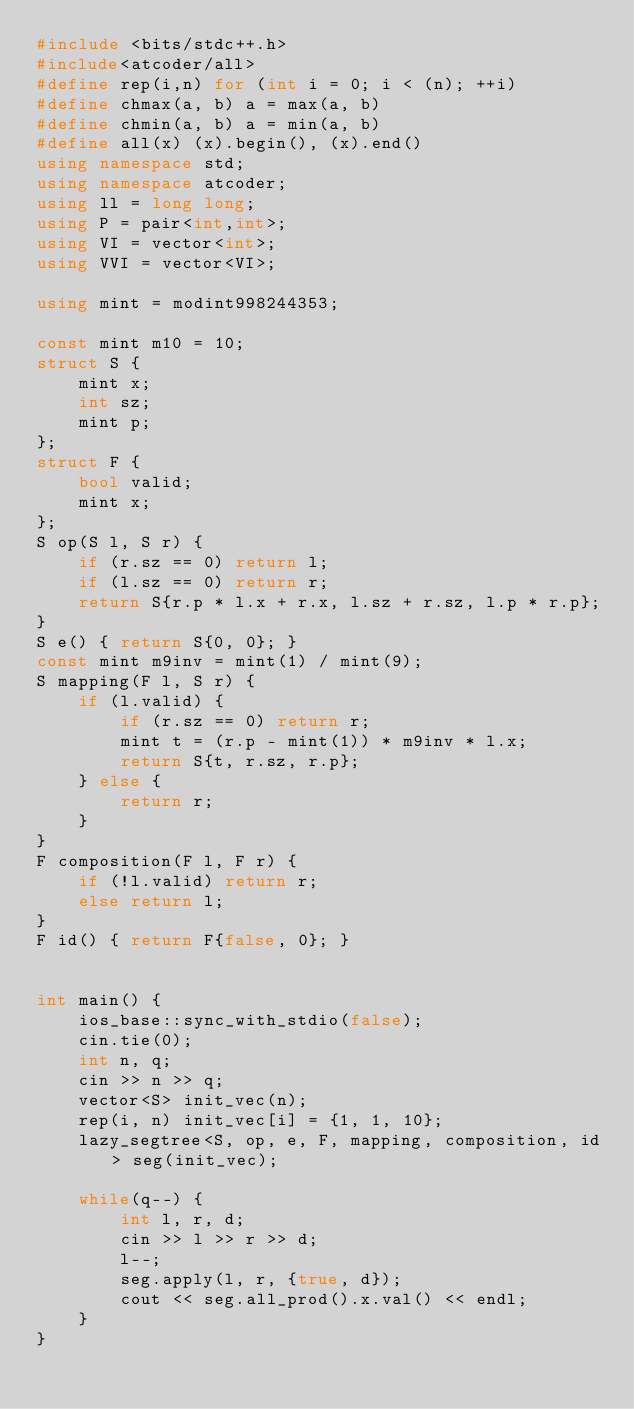Convert code to text. <code><loc_0><loc_0><loc_500><loc_500><_C++_>#include <bits/stdc++.h>
#include<atcoder/all>
#define rep(i,n) for (int i = 0; i < (n); ++i)
#define chmax(a, b) a = max(a, b)
#define chmin(a, b) a = min(a, b)
#define all(x) (x).begin(), (x).end()
using namespace std;
using namespace atcoder;
using ll = long long;
using P = pair<int,int>;
using VI = vector<int>;
using VVI = vector<VI>;

using mint = modint998244353;

const mint m10 = 10;
struct S {
    mint x;
    int sz;
    mint p;
};
struct F {
    bool valid;
    mint x;
};
S op(S l, S r) {
    if (r.sz == 0) return l;
    if (l.sz == 0) return r;
    return S{r.p * l.x + r.x, l.sz + r.sz, l.p * r.p};
}
S e() { return S{0, 0}; }
const mint m9inv = mint(1) / mint(9);
S mapping(F l, S r) { 
    if (l.valid) {
        if (r.sz == 0) return r;
        mint t = (r.p - mint(1)) * m9inv * l.x;
        return S{t, r.sz, r.p};
    } else {
        return r;
    }
}
F composition(F l, F r) {
    if (!l.valid) return r;
    else return l;
}
F id() { return F{false, 0}; }


int main() {
    ios_base::sync_with_stdio(false);
    cin.tie(0);
    int n, q;
    cin >> n >> q;
    vector<S> init_vec(n);
    rep(i, n) init_vec[i] = {1, 1, 10};
    lazy_segtree<S, op, e, F, mapping, composition, id> seg(init_vec);
    
    while(q--) {
        int l, r, d;
        cin >> l >> r >> d;
        l--;
        seg.apply(l, r, {true, d});
        cout << seg.all_prod().x.val() << endl;
    }
}</code> 